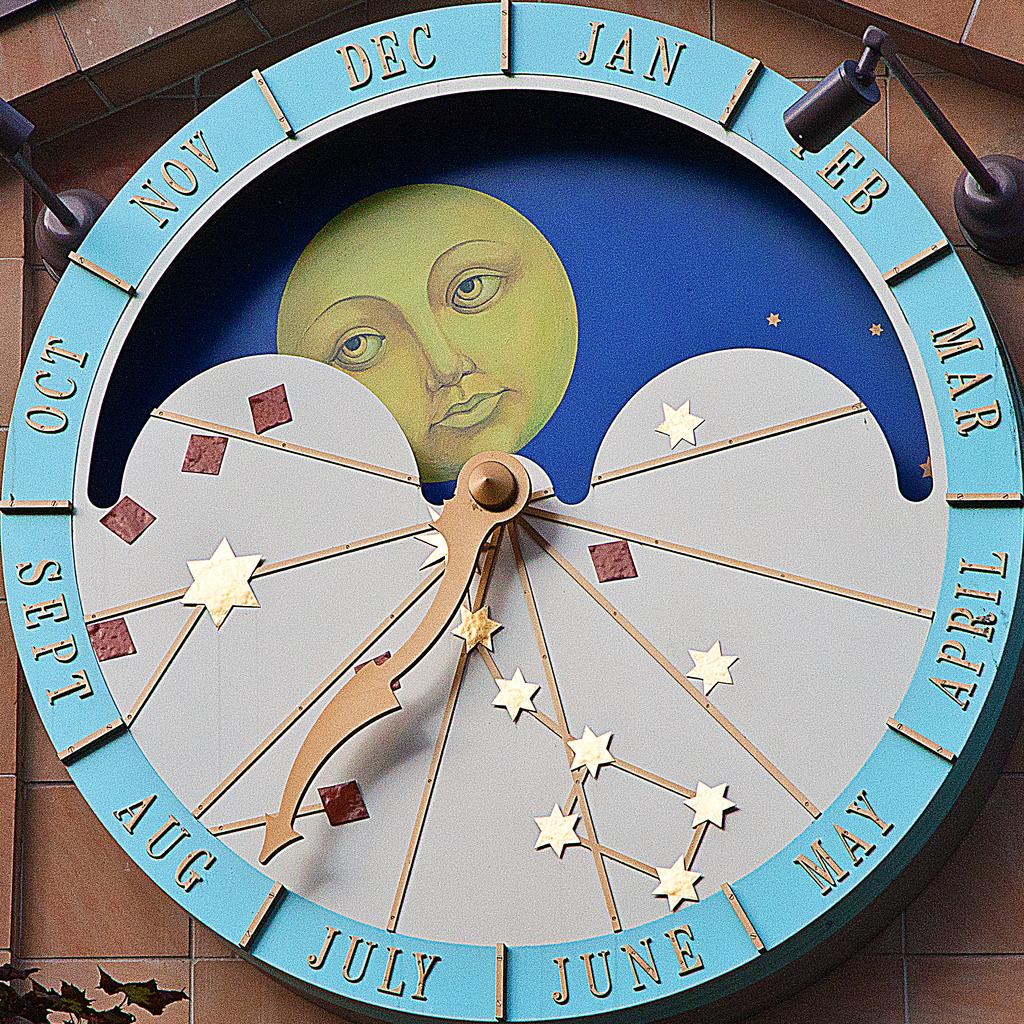<image>
Provide a brief description of the given image. A round disc has the months around the edge with an arrow pointing to Aug. 